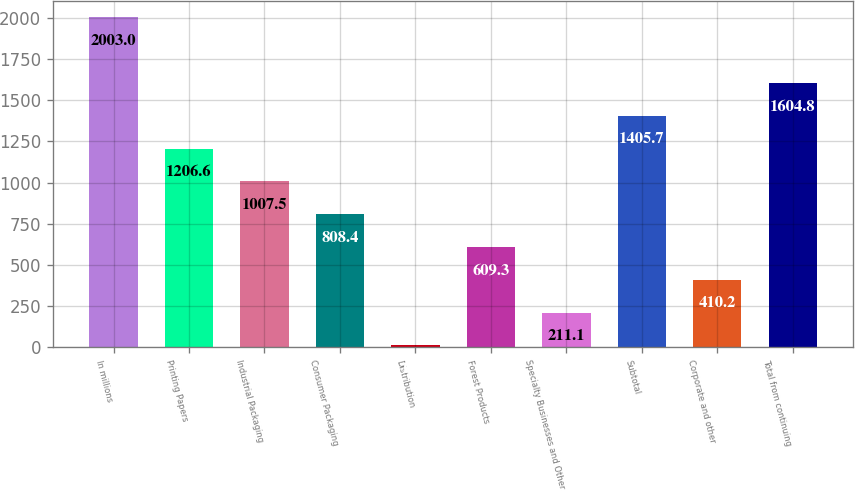Convert chart to OTSL. <chart><loc_0><loc_0><loc_500><loc_500><bar_chart><fcel>In millions<fcel>Printing Papers<fcel>Industrial Packaging<fcel>Consumer Packaging<fcel>Distribution<fcel>Forest Products<fcel>Specialty Businesses and Other<fcel>Subtotal<fcel>Corporate and other<fcel>Total from continuing<nl><fcel>2003<fcel>1206.6<fcel>1007.5<fcel>808.4<fcel>12<fcel>609.3<fcel>211.1<fcel>1405.7<fcel>410.2<fcel>1604.8<nl></chart> 